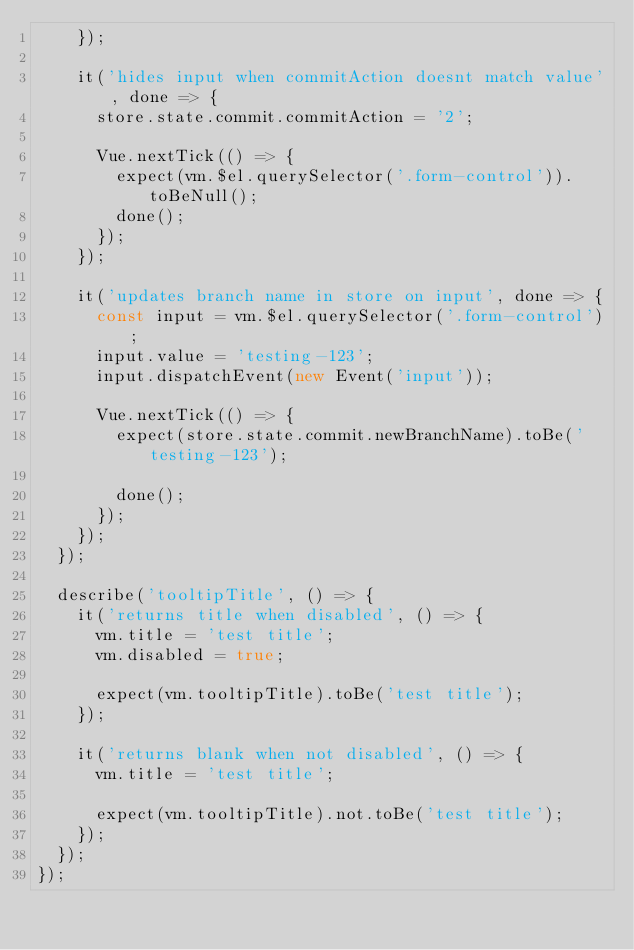Convert code to text. <code><loc_0><loc_0><loc_500><loc_500><_JavaScript_>    });

    it('hides input when commitAction doesnt match value', done => {
      store.state.commit.commitAction = '2';

      Vue.nextTick(() => {
        expect(vm.$el.querySelector('.form-control')).toBeNull();
        done();
      });
    });

    it('updates branch name in store on input', done => {
      const input = vm.$el.querySelector('.form-control');
      input.value = 'testing-123';
      input.dispatchEvent(new Event('input'));

      Vue.nextTick(() => {
        expect(store.state.commit.newBranchName).toBe('testing-123');

        done();
      });
    });
  });

  describe('tooltipTitle', () => {
    it('returns title when disabled', () => {
      vm.title = 'test title';
      vm.disabled = true;

      expect(vm.tooltipTitle).toBe('test title');
    });

    it('returns blank when not disabled', () => {
      vm.title = 'test title';

      expect(vm.tooltipTitle).not.toBe('test title');
    });
  });
});
</code> 